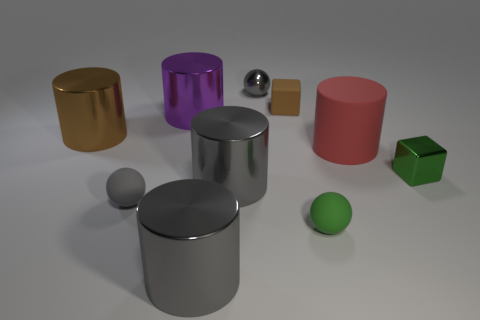Subtract all big purple metallic cylinders. How many cylinders are left? 4 Subtract all cubes. How many objects are left? 8 Subtract all green spheres. How many spheres are left? 2 Add 10 big yellow metallic spheres. How many big yellow metallic spheres exist? 10 Subtract 0 brown spheres. How many objects are left? 10 Subtract 1 cylinders. How many cylinders are left? 4 Subtract all green cylinders. Subtract all red balls. How many cylinders are left? 5 Subtract all red blocks. How many blue spheres are left? 0 Subtract all tiny gray metal spheres. Subtract all gray rubber spheres. How many objects are left? 8 Add 8 brown matte objects. How many brown matte objects are left? 9 